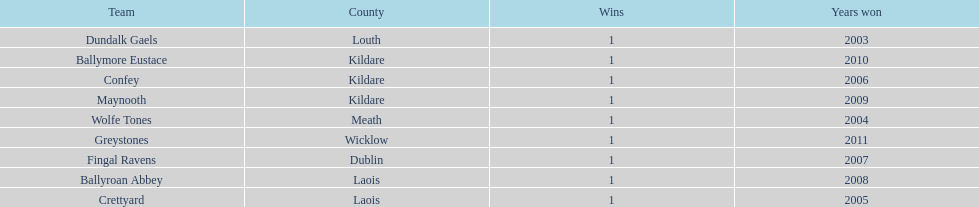What is the years won for each team 2011, 2010, 2009, 2008, 2007, 2006, 2005, 2004, 2003. 